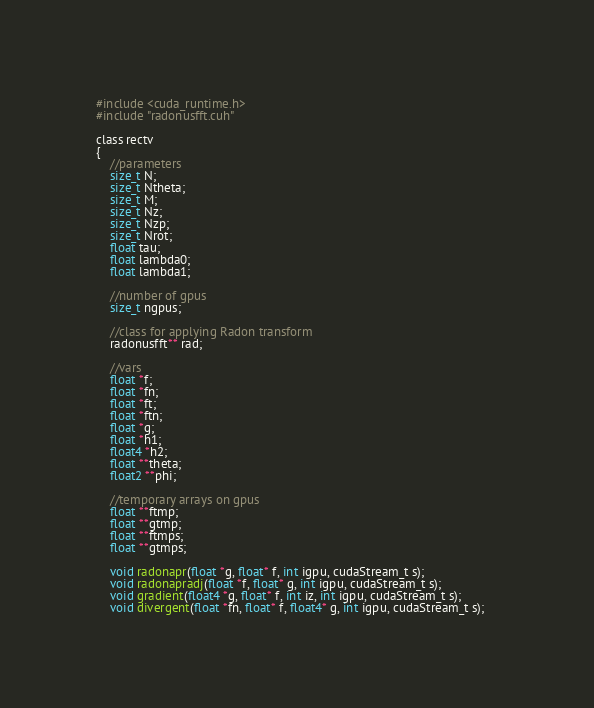<code> <loc_0><loc_0><loc_500><loc_500><_Cuda_>#include <cuda_runtime.h>
#include "radonusfft.cuh"

class rectv
{
	//parameters
	size_t N;
	size_t Ntheta;
	size_t M;
	size_t Nz;
	size_t Nzp;
	size_t Nrot;
	float tau;
	float lambda0;
	float lambda1;

	//number of gpus
	size_t ngpus;

	//class for applying Radon transform
	radonusfft** rad;

	//vars
	float *f;
	float *fn;
	float *ft;
	float *ftn;
	float *g;
	float *h1;
	float4 *h2;
	float **theta;
	float2 **phi;

	//temporary arrays on gpus
	float **ftmp;
	float **gtmp;
	float **ftmps;
	float **gtmps;

	void radonapr(float *g, float* f, int igpu, cudaStream_t s);
	void radonapradj(float *f, float* g, int igpu, cudaStream_t s);
	void gradient(float4 *g, float* f, int iz, int igpu, cudaStream_t s);
	void divergent(float *fn, float* f, float4* g, int igpu, cudaStream_t s);	</code> 